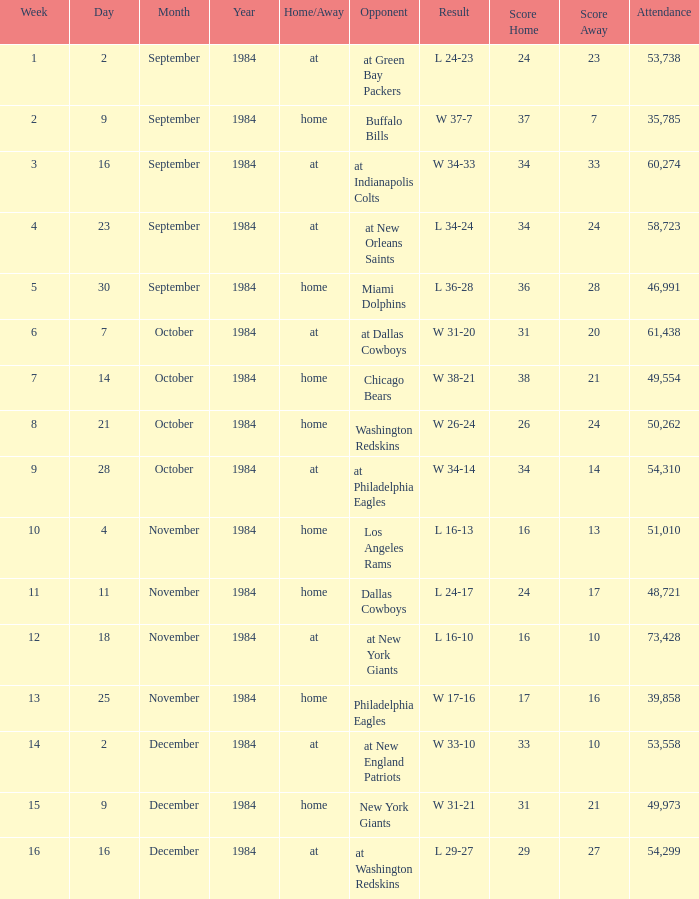Who was the opponent on October 14, 1984? Chicago Bears. 